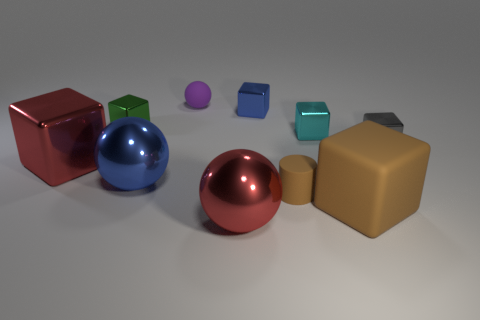Is the color of the metal ball that is right of the matte ball the same as the big metallic block?
Keep it short and to the point. Yes. Is the tiny cylinder the same color as the large matte cube?
Your answer should be compact. Yes. Is there a tiny rubber cylinder of the same color as the big matte block?
Provide a succinct answer. Yes. There is a blue object in front of the big red object to the left of the big red metallic object that is right of the small rubber sphere; what size is it?
Provide a succinct answer. Large. What number of other objects are there of the same size as the gray metal thing?
Your response must be concise. 5. How many small gray things are made of the same material as the tiny green object?
Your answer should be very brief. 1. There is a tiny matte object in front of the purple rubber object; what shape is it?
Offer a very short reply. Cylinder. Is the green thing made of the same material as the tiny object that is in front of the gray object?
Keep it short and to the point. No. Is there a large yellow metal block?
Give a very brief answer. No. There is a big red shiny thing that is to the left of the blue shiny object that is to the left of the blue metallic cube; are there any large red shiny things that are in front of it?
Offer a terse response. Yes. 